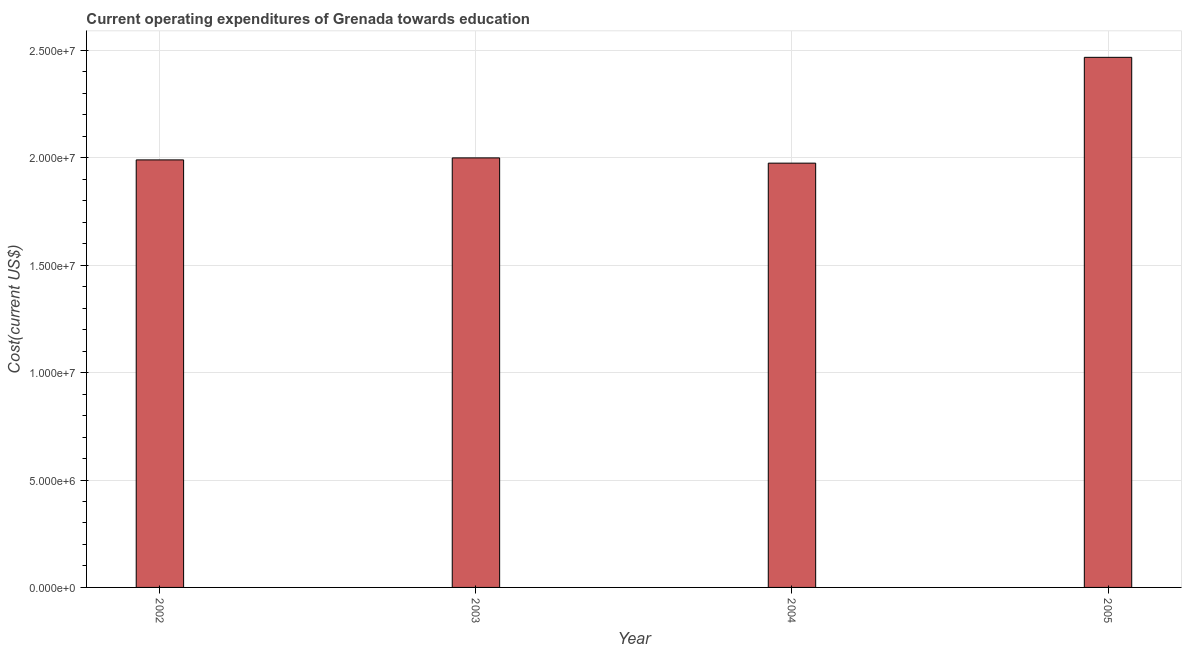Does the graph contain grids?
Your answer should be very brief. Yes. What is the title of the graph?
Your response must be concise. Current operating expenditures of Grenada towards education. What is the label or title of the X-axis?
Provide a succinct answer. Year. What is the label or title of the Y-axis?
Your answer should be compact. Cost(current US$). What is the education expenditure in 2004?
Make the answer very short. 1.98e+07. Across all years, what is the maximum education expenditure?
Give a very brief answer. 2.47e+07. Across all years, what is the minimum education expenditure?
Provide a short and direct response. 1.98e+07. What is the sum of the education expenditure?
Provide a short and direct response. 8.43e+07. What is the difference between the education expenditure in 2003 and 2004?
Keep it short and to the point. 2.44e+05. What is the average education expenditure per year?
Make the answer very short. 2.11e+07. What is the median education expenditure?
Keep it short and to the point. 2.00e+07. In how many years, is the education expenditure greater than 16000000 US$?
Make the answer very short. 4. Do a majority of the years between 2002 and 2005 (inclusive) have education expenditure greater than 13000000 US$?
Provide a succinct answer. Yes. What is the ratio of the education expenditure in 2003 to that in 2005?
Your response must be concise. 0.81. What is the difference between the highest and the second highest education expenditure?
Provide a short and direct response. 4.68e+06. Is the sum of the education expenditure in 2002 and 2005 greater than the maximum education expenditure across all years?
Keep it short and to the point. Yes. What is the difference between the highest and the lowest education expenditure?
Make the answer very short. 4.93e+06. Are all the bars in the graph horizontal?
Give a very brief answer. No. How many years are there in the graph?
Offer a terse response. 4. Are the values on the major ticks of Y-axis written in scientific E-notation?
Offer a very short reply. Yes. What is the Cost(current US$) in 2002?
Give a very brief answer. 1.99e+07. What is the Cost(current US$) in 2003?
Your answer should be very brief. 2.00e+07. What is the Cost(current US$) of 2004?
Give a very brief answer. 1.98e+07. What is the Cost(current US$) in 2005?
Make the answer very short. 2.47e+07. What is the difference between the Cost(current US$) in 2002 and 2003?
Offer a terse response. -9.27e+04. What is the difference between the Cost(current US$) in 2002 and 2004?
Your answer should be compact. 1.51e+05. What is the difference between the Cost(current US$) in 2002 and 2005?
Keep it short and to the point. -4.78e+06. What is the difference between the Cost(current US$) in 2003 and 2004?
Offer a terse response. 2.44e+05. What is the difference between the Cost(current US$) in 2003 and 2005?
Keep it short and to the point. -4.68e+06. What is the difference between the Cost(current US$) in 2004 and 2005?
Ensure brevity in your answer.  -4.93e+06. What is the ratio of the Cost(current US$) in 2002 to that in 2004?
Give a very brief answer. 1.01. What is the ratio of the Cost(current US$) in 2002 to that in 2005?
Your answer should be very brief. 0.81. What is the ratio of the Cost(current US$) in 2003 to that in 2005?
Your answer should be very brief. 0.81. 